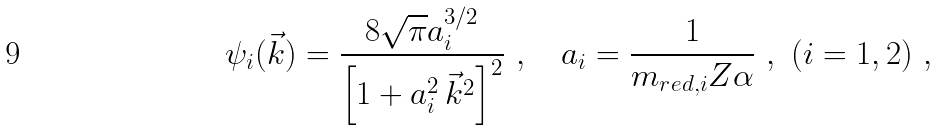<formula> <loc_0><loc_0><loc_500><loc_500>\psi _ { i } ( \vec { k } ) = \frac { 8 \sqrt { \pi } a _ { i } ^ { 3 / 2 } } { \left [ 1 + a _ { i } ^ { 2 } \, \vec { k } ^ { 2 } \right ] ^ { 2 } } \ , \quad a _ { i } = \frac { 1 } { m _ { r e d , i } Z \alpha } \ , \ ( i = 1 , 2 ) \ ,</formula> 